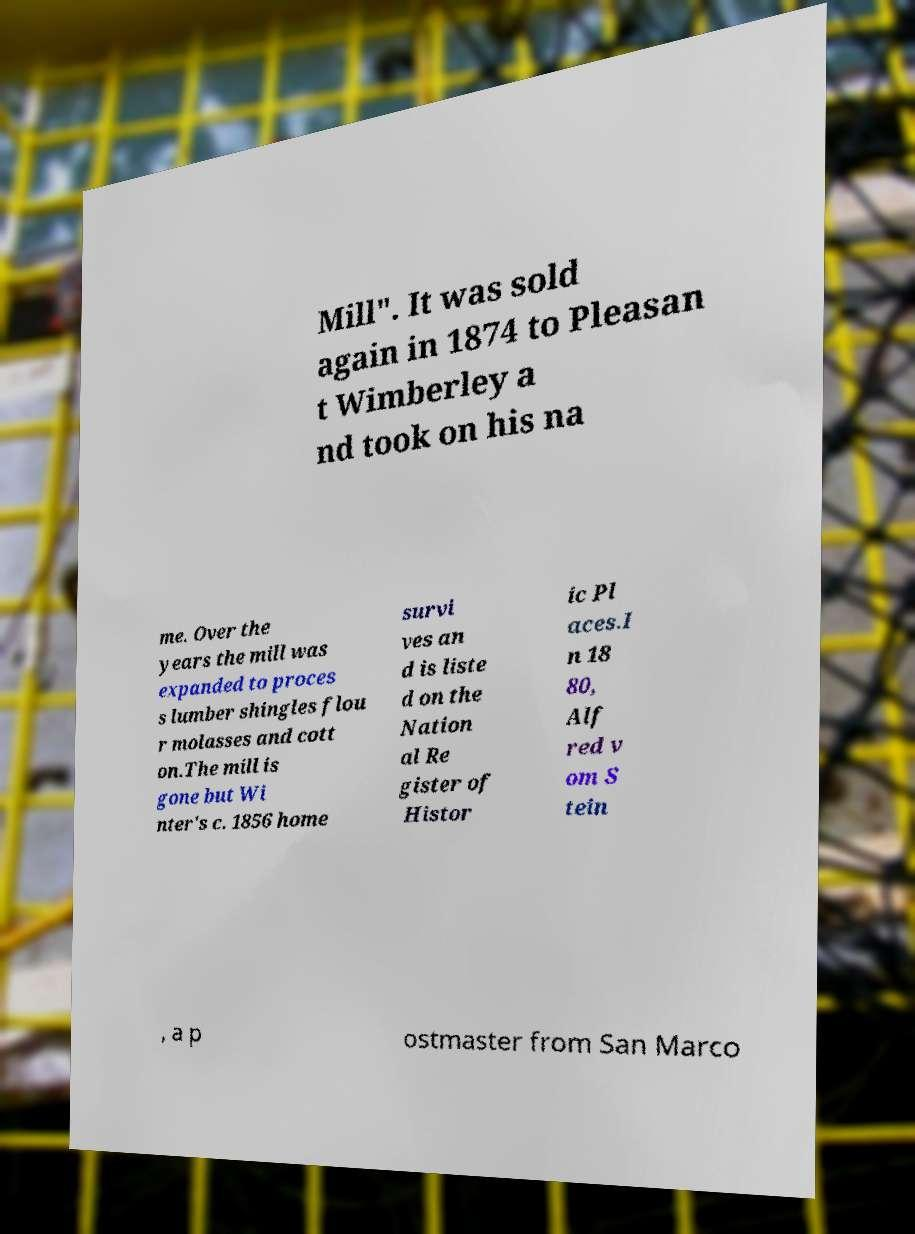What messages or text are displayed in this image? I need them in a readable, typed format. Mill". It was sold again in 1874 to Pleasan t Wimberley a nd took on his na me. Over the years the mill was expanded to proces s lumber shingles flou r molasses and cott on.The mill is gone but Wi nter's c. 1856 home survi ves an d is liste d on the Nation al Re gister of Histor ic Pl aces.I n 18 80, Alf red v om S tein , a p ostmaster from San Marco 